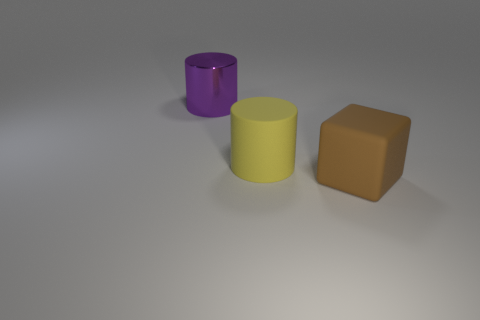Add 2 yellow things. How many objects exist? 5 Subtract all cylinders. How many objects are left? 1 Add 1 large purple cylinders. How many large purple cylinders are left? 2 Add 2 big green rubber cubes. How many big green rubber cubes exist? 2 Subtract 1 purple cylinders. How many objects are left? 2 Subtract all red metal blocks. Subtract all big purple objects. How many objects are left? 2 